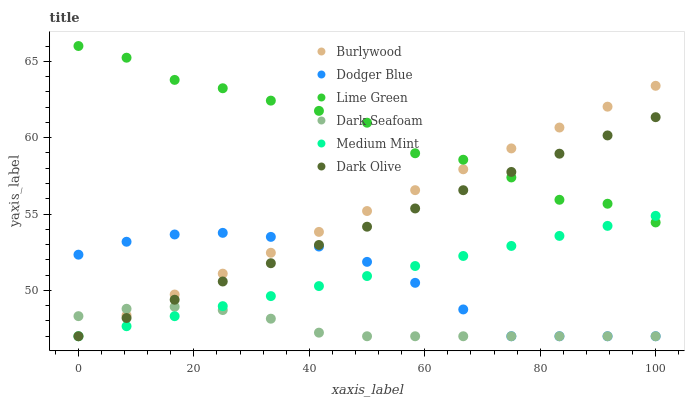Does Dark Seafoam have the minimum area under the curve?
Answer yes or no. Yes. Does Lime Green have the maximum area under the curve?
Answer yes or no. Yes. Does Burlywood have the minimum area under the curve?
Answer yes or no. No. Does Burlywood have the maximum area under the curve?
Answer yes or no. No. Is Medium Mint the smoothest?
Answer yes or no. Yes. Is Lime Green the roughest?
Answer yes or no. Yes. Is Burlywood the smoothest?
Answer yes or no. No. Is Burlywood the roughest?
Answer yes or no. No. Does Medium Mint have the lowest value?
Answer yes or no. Yes. Does Lime Green have the lowest value?
Answer yes or no. No. Does Lime Green have the highest value?
Answer yes or no. Yes. Does Burlywood have the highest value?
Answer yes or no. No. Is Dodger Blue less than Lime Green?
Answer yes or no. Yes. Is Lime Green greater than Dark Seafoam?
Answer yes or no. Yes. Does Dark Seafoam intersect Dark Olive?
Answer yes or no. Yes. Is Dark Seafoam less than Dark Olive?
Answer yes or no. No. Is Dark Seafoam greater than Dark Olive?
Answer yes or no. No. Does Dodger Blue intersect Lime Green?
Answer yes or no. No. 